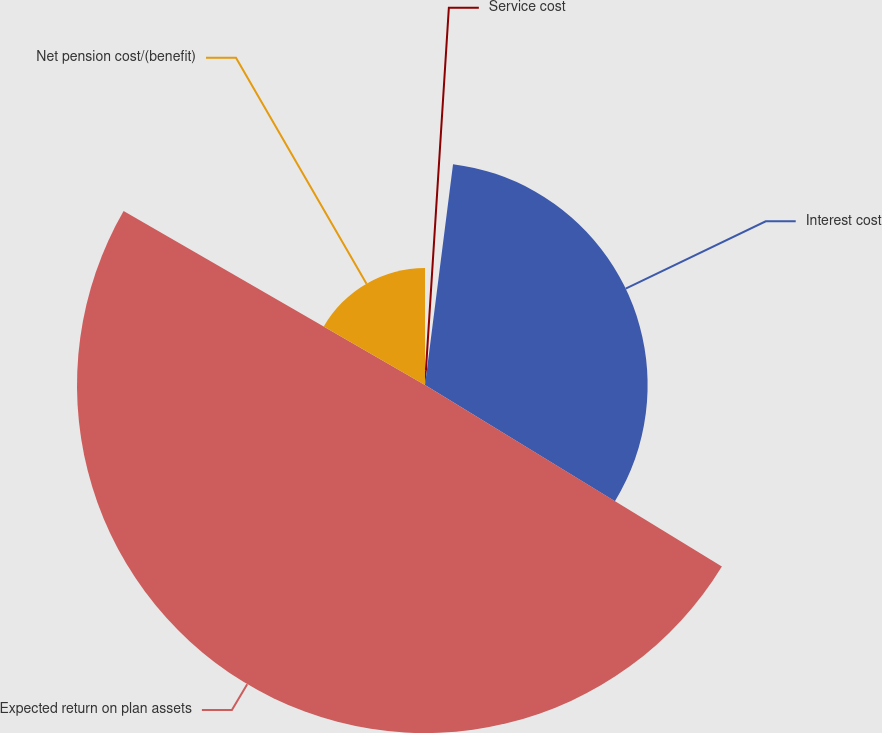<chart> <loc_0><loc_0><loc_500><loc_500><pie_chart><fcel>Service cost<fcel>Interest cost<fcel>Expected return on plan assets<fcel>Net pension cost/(benefit)<nl><fcel>2.01%<fcel>31.73%<fcel>49.6%<fcel>16.67%<nl></chart> 